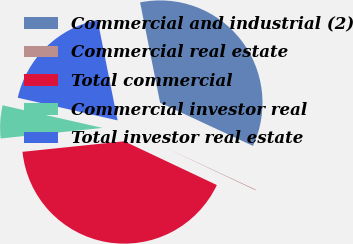<chart> <loc_0><loc_0><loc_500><loc_500><pie_chart><fcel>Commercial and industrial (2)<fcel>Commercial real estate<fcel>Total commercial<fcel>Commercial investor real<fcel>Total investor real estate<nl><fcel>35.05%<fcel>0.11%<fcel>41.33%<fcel>5.19%<fcel>18.32%<nl></chart> 